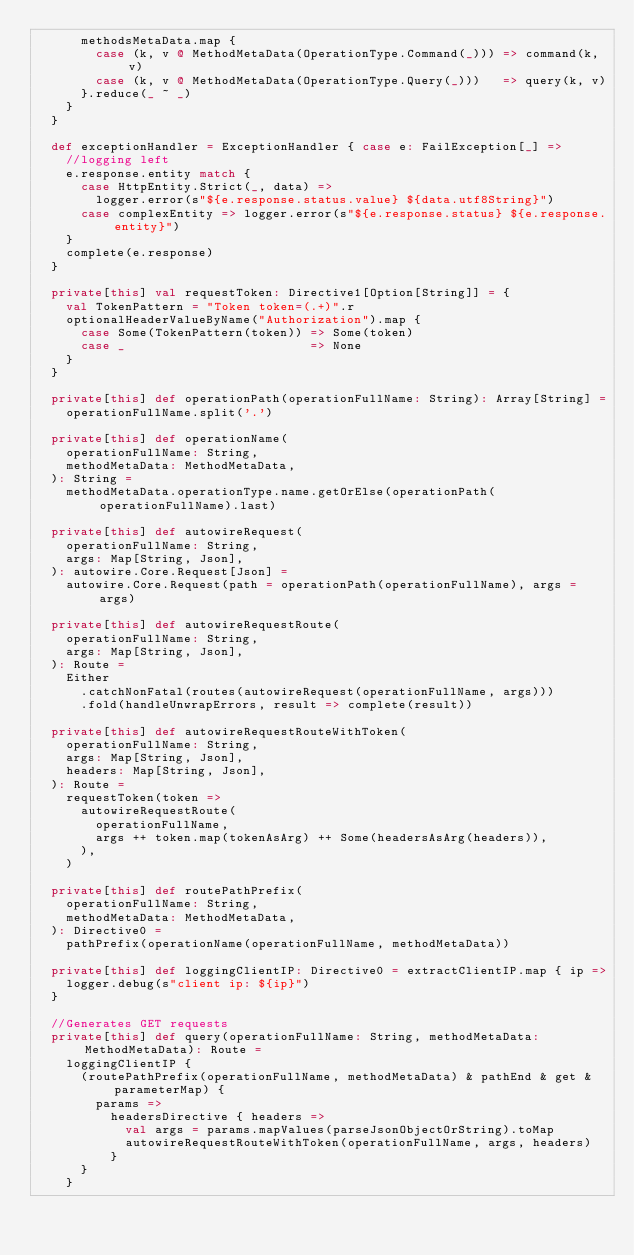<code> <loc_0><loc_0><loc_500><loc_500><_Scala_>      methodsMetaData.map {
        case (k, v @ MethodMetaData(OperationType.Command(_))) => command(k, v)
        case (k, v @ MethodMetaData(OperationType.Query(_)))   => query(k, v)
      }.reduce(_ ~ _)
    }
  }

  def exceptionHandler = ExceptionHandler { case e: FailException[_] =>
    //logging left
    e.response.entity match {
      case HttpEntity.Strict(_, data) =>
        logger.error(s"${e.response.status.value} ${data.utf8String}")
      case complexEntity => logger.error(s"${e.response.status} ${e.response.entity}")
    }
    complete(e.response)
  }

  private[this] val requestToken: Directive1[Option[String]] = {
    val TokenPattern = "Token token=(.+)".r
    optionalHeaderValueByName("Authorization").map {
      case Some(TokenPattern(token)) => Some(token)
      case _                         => None
    }
  }

  private[this] def operationPath(operationFullName: String): Array[String] =
    operationFullName.split('.')

  private[this] def operationName(
    operationFullName: String,
    methodMetaData: MethodMetaData,
  ): String =
    methodMetaData.operationType.name.getOrElse(operationPath(operationFullName).last)

  private[this] def autowireRequest(
    operationFullName: String,
    args: Map[String, Json],
  ): autowire.Core.Request[Json] =
    autowire.Core.Request(path = operationPath(operationFullName), args = args)

  private[this] def autowireRequestRoute(
    operationFullName: String,
    args: Map[String, Json],
  ): Route =
    Either
      .catchNonFatal(routes(autowireRequest(operationFullName, args)))
      .fold(handleUnwrapErrors, result => complete(result))

  private[this] def autowireRequestRouteWithToken(
    operationFullName: String,
    args: Map[String, Json],
    headers: Map[String, Json],
  ): Route =
    requestToken(token =>
      autowireRequestRoute(
        operationFullName,
        args ++ token.map(tokenAsArg) ++ Some(headersAsArg(headers)),
      ),
    )

  private[this] def routePathPrefix(
    operationFullName: String,
    methodMetaData: MethodMetaData,
  ): Directive0 =
    pathPrefix(operationName(operationFullName, methodMetaData))

  private[this] def loggingClientIP: Directive0 = extractClientIP.map { ip =>
    logger.debug(s"client ip: ${ip}")
  }

  //Generates GET requests
  private[this] def query(operationFullName: String, methodMetaData: MethodMetaData): Route =
    loggingClientIP {
      (routePathPrefix(operationFullName, methodMetaData) & pathEnd & get & parameterMap) {
        params =>
          headersDirective { headers =>
            val args = params.mapValues(parseJsonObjectOrString).toMap
            autowireRequestRouteWithToken(operationFullName, args, headers)
          }
      }
    }
</code> 